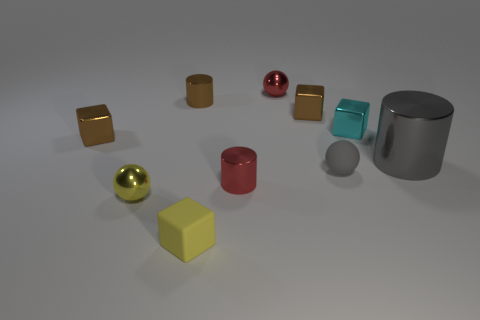What shape is the tiny thing that is both in front of the small cyan metal thing and behind the large cylinder?
Your answer should be very brief. Cube. Does the large metal object have the same color as the shiny cylinder that is in front of the big shiny cylinder?
Ensure brevity in your answer.  No. There is a block that is on the left side of the yellow block; is it the same size as the small cyan object?
Your answer should be compact. Yes. There is a small red thing that is the same shape as the gray rubber thing; what is it made of?
Your answer should be very brief. Metal. Is the shape of the gray rubber thing the same as the cyan object?
Offer a very short reply. No. There is a metallic block that is right of the small gray object; what number of tiny cyan objects are on the left side of it?
Make the answer very short. 0. There is a small yellow thing that is made of the same material as the gray sphere; what shape is it?
Offer a terse response. Cube. What number of brown objects are tiny shiny blocks or large objects?
Your answer should be compact. 2. There is a brown block that is right of the tiny red metallic object that is behind the tiny gray rubber thing; are there any small cyan objects left of it?
Your answer should be very brief. No. Is the number of metallic spheres less than the number of small matte cubes?
Your response must be concise. No. 